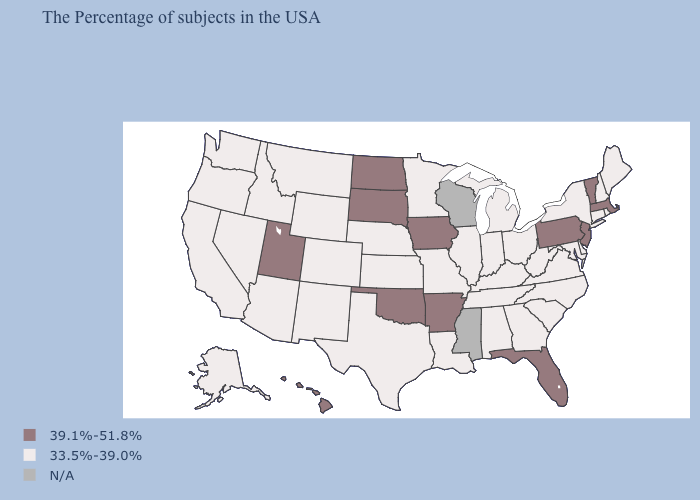Which states have the lowest value in the Northeast?
Give a very brief answer. Maine, Rhode Island, New Hampshire, Connecticut, New York. What is the value of Arizona?
Be succinct. 33.5%-39.0%. Which states have the lowest value in the MidWest?
Quick response, please. Ohio, Michigan, Indiana, Illinois, Missouri, Minnesota, Kansas, Nebraska. Name the states that have a value in the range 39.1%-51.8%?
Answer briefly. Massachusetts, Vermont, New Jersey, Pennsylvania, Florida, Arkansas, Iowa, Oklahoma, South Dakota, North Dakota, Utah, Hawaii. What is the highest value in the USA?
Write a very short answer. 39.1%-51.8%. What is the highest value in the South ?
Give a very brief answer. 39.1%-51.8%. What is the value of Connecticut?
Short answer required. 33.5%-39.0%. What is the lowest value in the USA?
Concise answer only. 33.5%-39.0%. What is the value of New York?
Answer briefly. 33.5%-39.0%. What is the highest value in the USA?
Write a very short answer. 39.1%-51.8%. What is the lowest value in states that border Missouri?
Write a very short answer. 33.5%-39.0%. Is the legend a continuous bar?
Write a very short answer. No. What is the lowest value in the South?
Give a very brief answer. 33.5%-39.0%. 